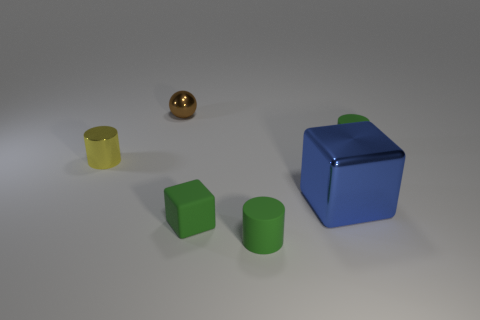Subtract all green matte cylinders. How many cylinders are left? 1 Add 4 yellow objects. How many objects exist? 10 Subtract all blue blocks. How many blocks are left? 1 Subtract all cubes. How many objects are left? 4 Subtract all gray blocks. How many green cylinders are left? 2 Subtract all big blue metal blocks. Subtract all red shiny cubes. How many objects are left? 5 Add 6 blue objects. How many blue objects are left? 7 Add 1 small green matte cubes. How many small green matte cubes exist? 2 Subtract 0 brown cubes. How many objects are left? 6 Subtract 2 cubes. How many cubes are left? 0 